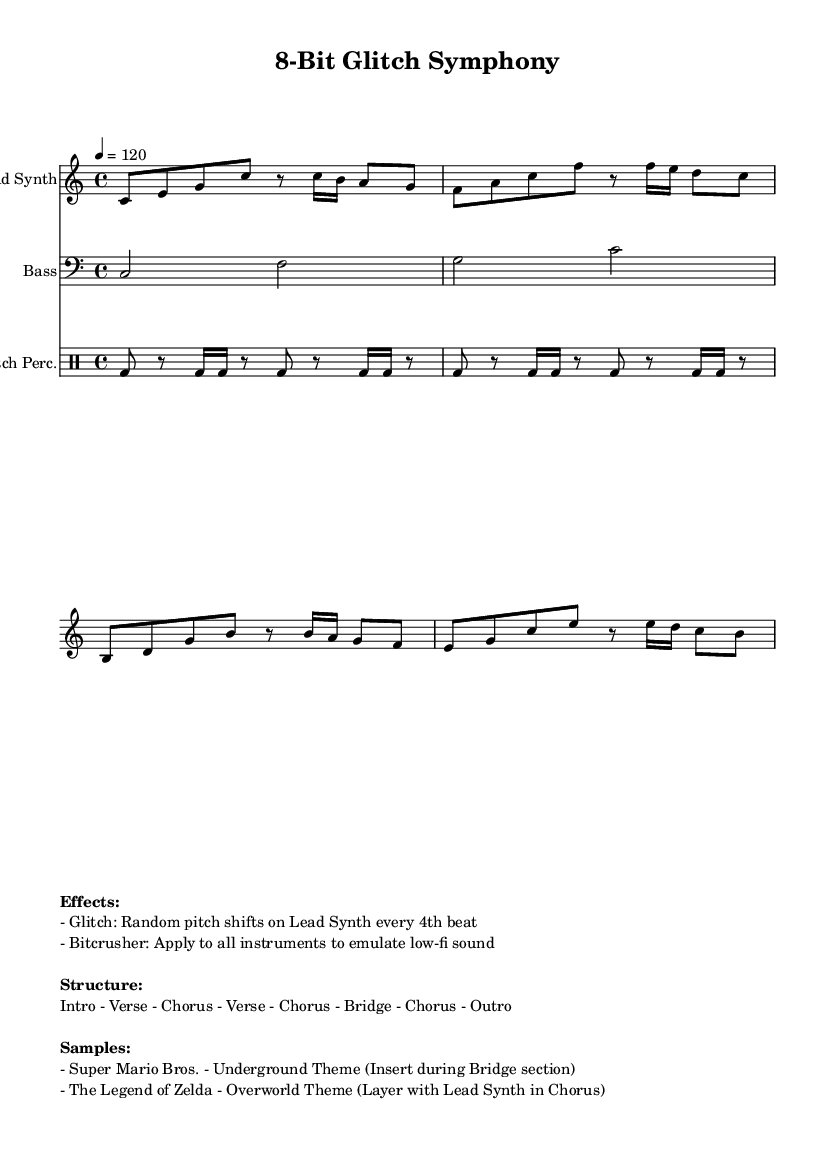What is the key signature of this music? The key signature is C major, which has no sharps or flats.
Answer: C major What is the time signature of this piece? The time signature is indicated as 4/4, meaning there are four beats in each measure.
Answer: 4/4 What is the tempo marking given in the score? The tempo is set at 120 beats per minute, indicated by the "4 = 120" marking.
Answer: 120 How many measures are in the lead synth section? There are a total of four measures in the lead synth part, calculated by counting the bars in the provided music notation.
Answer: Four measures What does "glitch" refer to in the effects section? "Glitch" implies that there are random pitch shifts applied to the lead synth every fourth beat, creating a unique sound characteristic.
Answer: Random pitch shifts In which section is the Super Mario Bros. theme inserted? The Super Mario Bros. theme is inserted during the Bridge section, according to the specified structure of the piece.
Answer: Bridge section What instrument is “Glitch Perc.” representing? "Glitch Perc." represents the percussion section designed for this piece, specifically using glitch-inspired techniques.
Answer: Percussion 